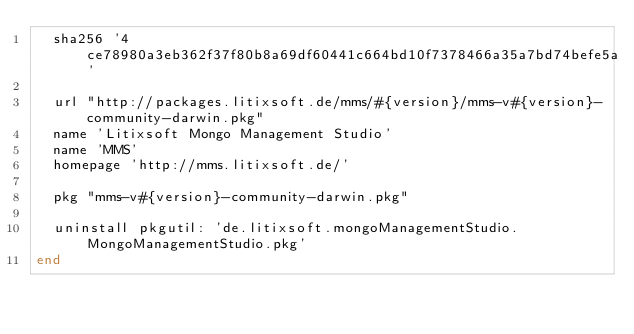<code> <loc_0><loc_0><loc_500><loc_500><_Ruby_>  sha256 '4ce78980a3eb362f37f80b8a69df60441c664bd10f7378466a35a7bd74befe5a'

  url "http://packages.litixsoft.de/mms/#{version}/mms-v#{version}-community-darwin.pkg"
  name 'Litixsoft Mongo Management Studio'
  name 'MMS'
  homepage 'http://mms.litixsoft.de/'

  pkg "mms-v#{version}-community-darwin.pkg"

  uninstall pkgutil: 'de.litixsoft.mongoManagementStudio.MongoManagementStudio.pkg'
end
</code> 